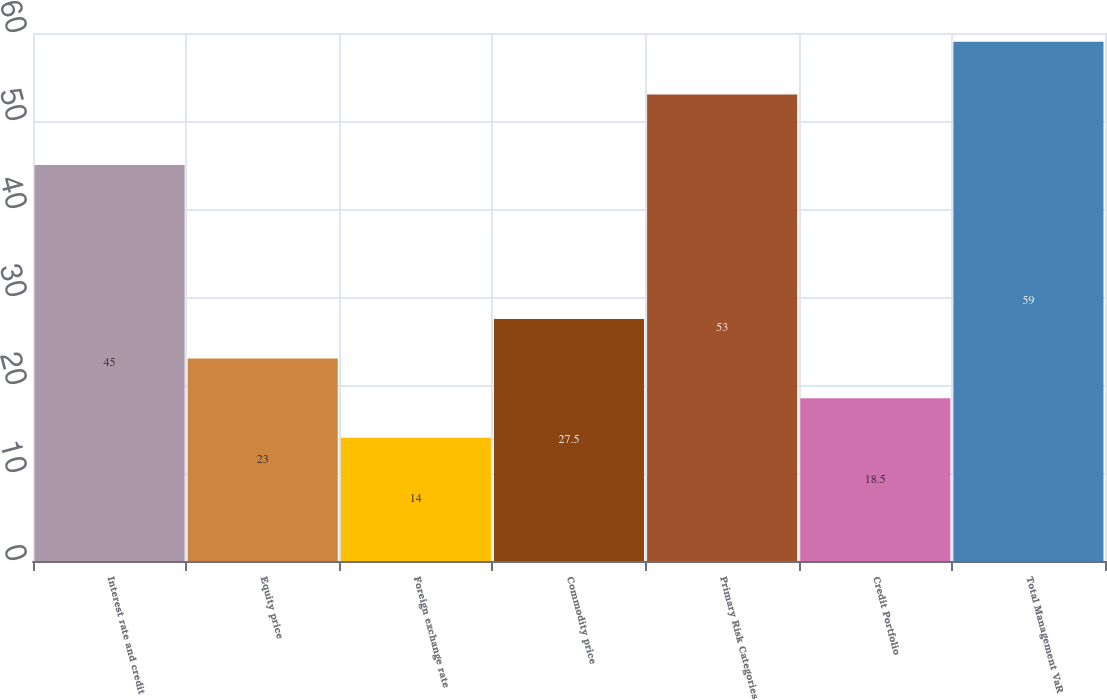<chart> <loc_0><loc_0><loc_500><loc_500><bar_chart><fcel>Interest rate and credit<fcel>Equity price<fcel>Foreign exchange rate<fcel>Commodity price<fcel>Primary Risk Categories<fcel>Credit Portfolio<fcel>Total Management VaR<nl><fcel>45<fcel>23<fcel>14<fcel>27.5<fcel>53<fcel>18.5<fcel>59<nl></chart> 